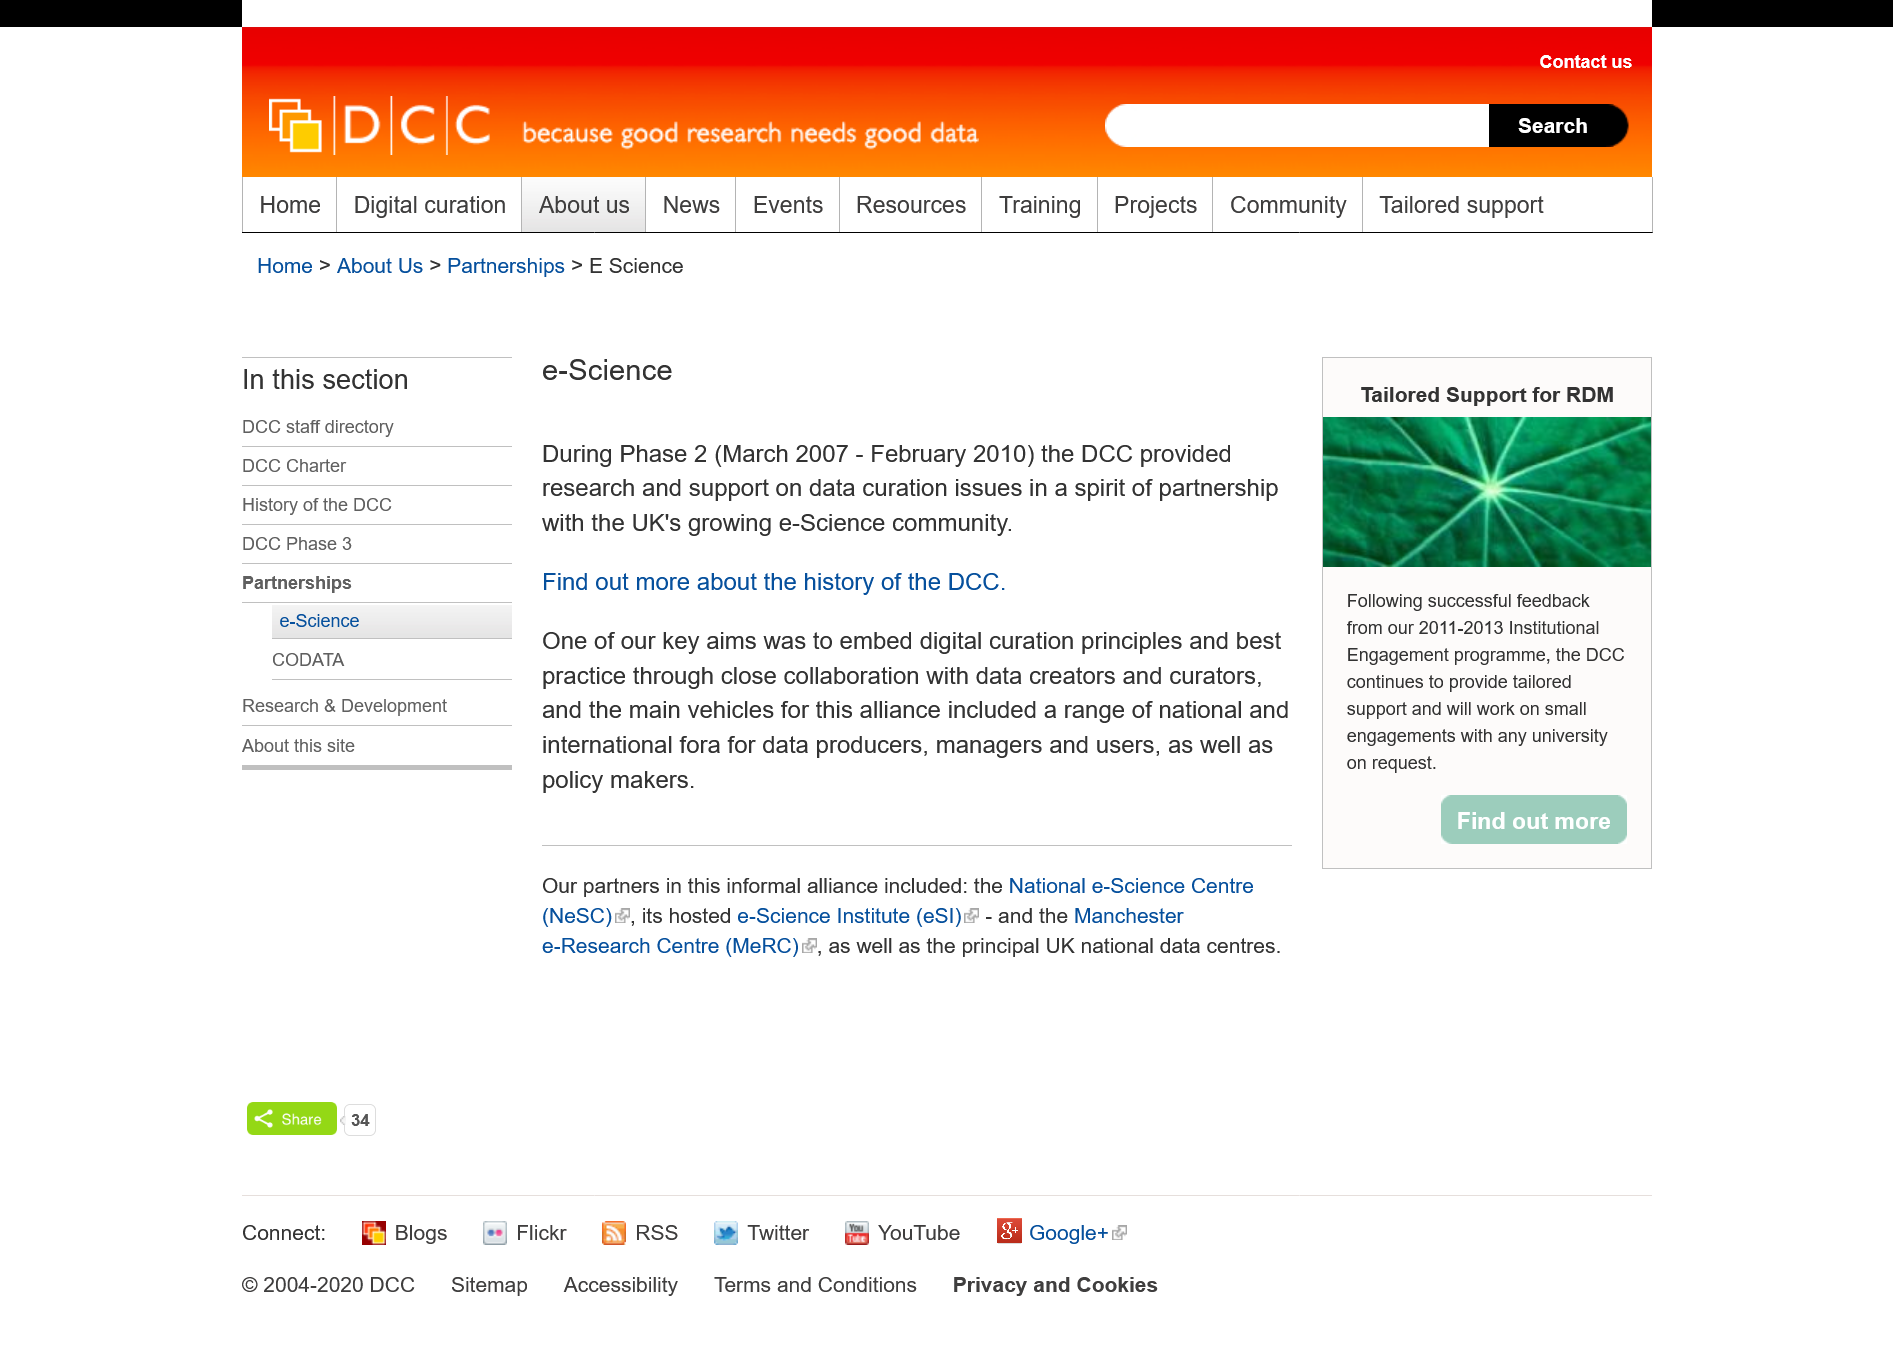Outline some significant characteristics in this image. The Digital Curation Centre (DCC) is involved with e-Science. Phase 2 of the e-Science project took place between March 2007 and February 2010. Yes, the UK's e-Science community is growing. 